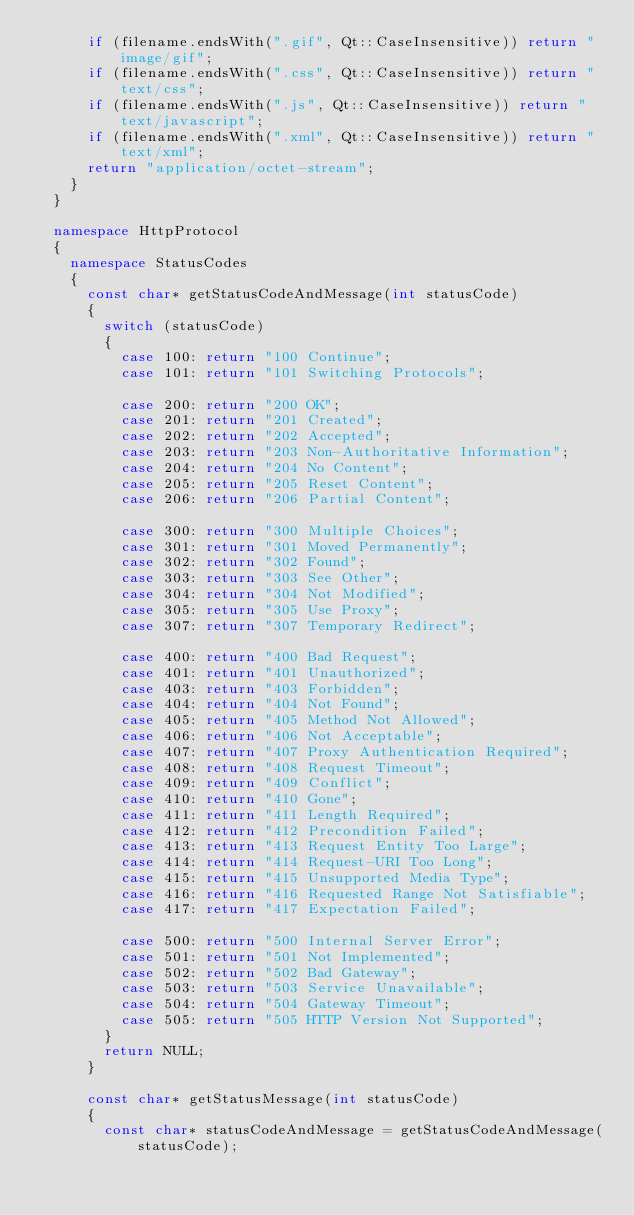Convert code to text. <code><loc_0><loc_0><loc_500><loc_500><_C++_>			if (filename.endsWith(".gif", Qt::CaseInsensitive)) return "image/gif";
			if (filename.endsWith(".css", Qt::CaseInsensitive)) return "text/css";
			if (filename.endsWith(".js", Qt::CaseInsensitive)) return "text/javascript";
			if (filename.endsWith(".xml", Qt::CaseInsensitive)) return "text/xml";
			return "application/octet-stream";
		}
	}

	namespace HttpProtocol
	{
		namespace StatusCodes
		{
			const char* getStatusCodeAndMessage(int statusCode)
			{
				switch (statusCode)
				{
					case 100: return "100 Continue";
					case 101: return "101 Switching Protocols";

					case 200: return "200 OK";
					case 201: return "201 Created";
					case 202: return "202 Accepted";
					case 203: return "203 Non-Authoritative Information";
					case 204: return "204 No Content";
					case 205: return "205 Reset Content";
					case 206: return "206 Partial Content";

					case 300: return "300 Multiple Choices";
					case 301: return "301 Moved Permanently";
					case 302: return "302 Found";
					case 303: return "303 See Other";
					case 304: return "304 Not Modified";
					case 305: return "305 Use Proxy";
					case 307: return "307 Temporary Redirect";

					case 400: return "400 Bad Request";
					case 401: return "401 Unauthorized";
					case 403: return "403 Forbidden";
					case 404: return "404 Not Found";
					case 405: return "405 Method Not Allowed";
					case 406: return "406 Not Acceptable";
					case 407: return "407 Proxy Authentication Required";
					case 408: return "408 Request Timeout";
					case 409: return "409 Conflict";
					case 410: return "410 Gone";
					case 411: return "411 Length Required";
					case 412: return "412 Precondition Failed";
					case 413: return "413 Request Entity Too Large";
					case 414: return "414 Request-URI Too Long";
					case 415: return "415 Unsupported Media Type";
					case 416: return "416 Requested Range Not Satisfiable";
					case 417: return "417 Expectation Failed";

					case 500: return "500 Internal Server Error";
					case 501: return "501 Not Implemented";
					case 502: return "502 Bad Gateway";
					case 503: return "503 Service Unavailable";
					case 504: return "504 Gateway Timeout";
					case 505: return "505 HTTP Version Not Supported";
				}
				return NULL;
			}

			const char* getStatusMessage(int statusCode)
			{
				const char* statusCodeAndMessage = getStatusCodeAndMessage(statusCode);</code> 